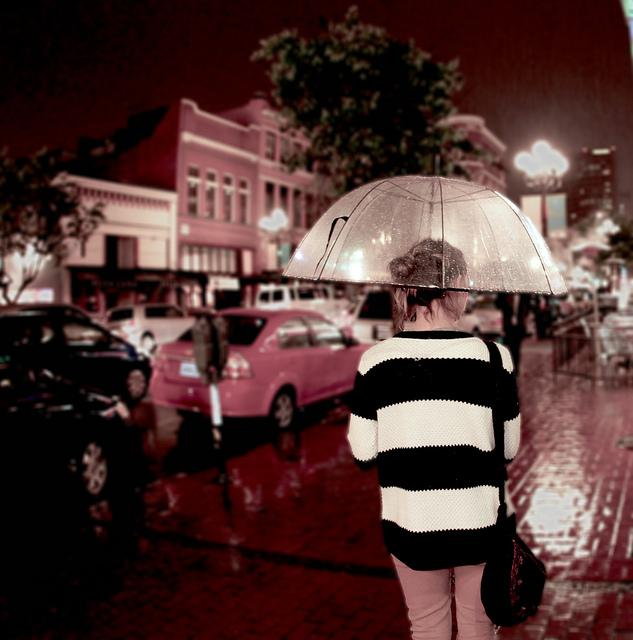Why is the woman using an umbrella? Please explain your reasoning. rain. The woman doesn't want to get wet. 